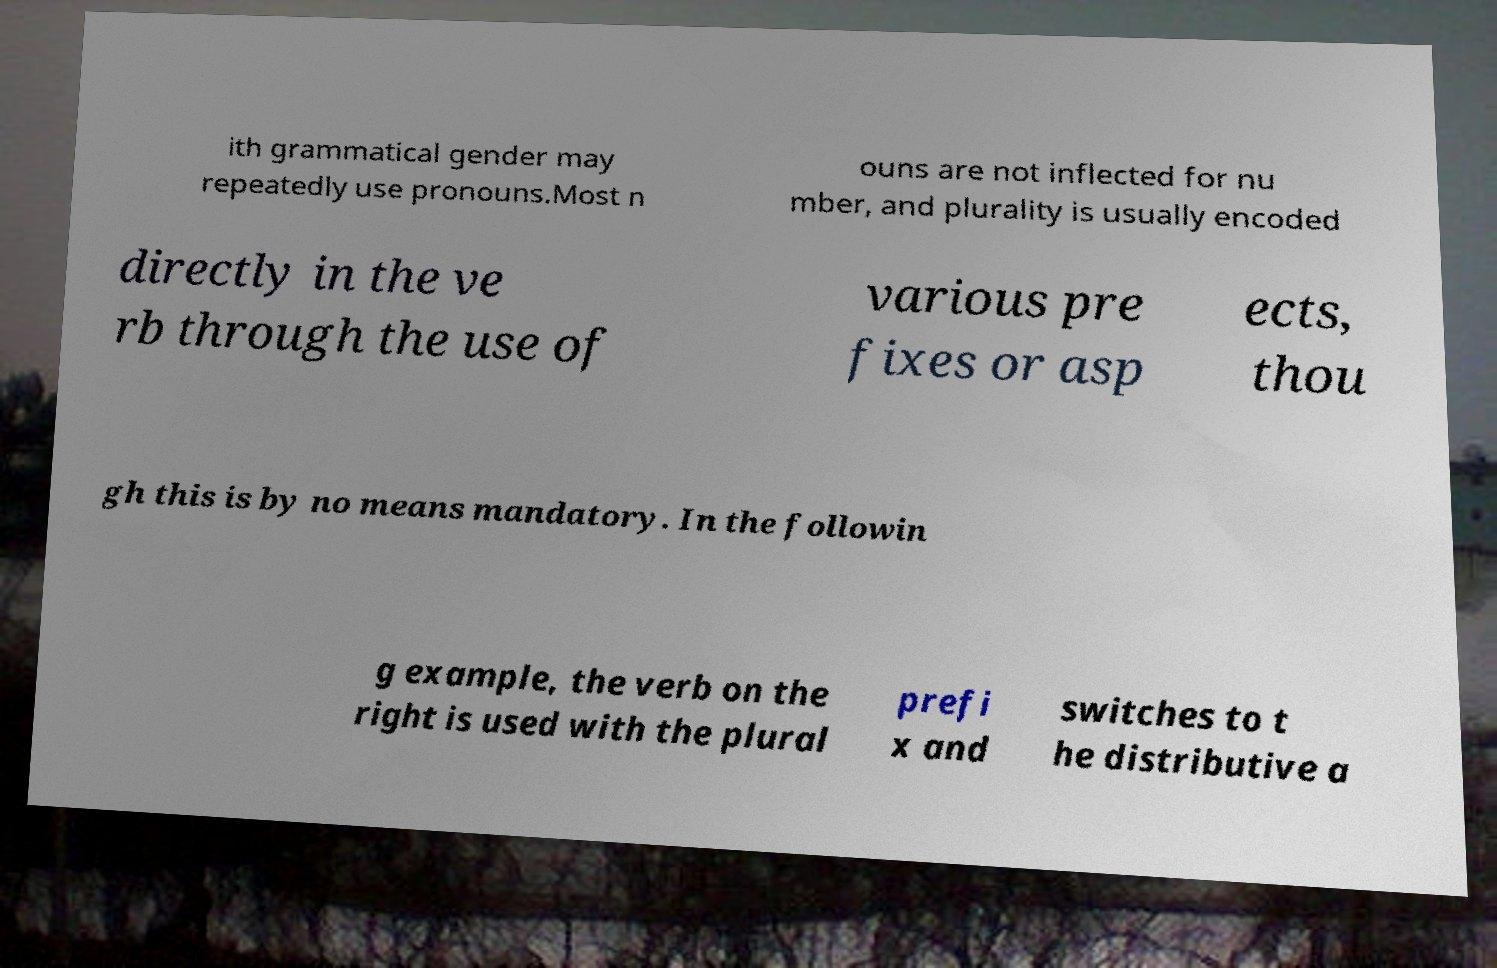Please identify and transcribe the text found in this image. ith grammatical gender may repeatedly use pronouns.Most n ouns are not inflected for nu mber, and plurality is usually encoded directly in the ve rb through the use of various pre fixes or asp ects, thou gh this is by no means mandatory. In the followin g example, the verb on the right is used with the plural prefi x and switches to t he distributive a 